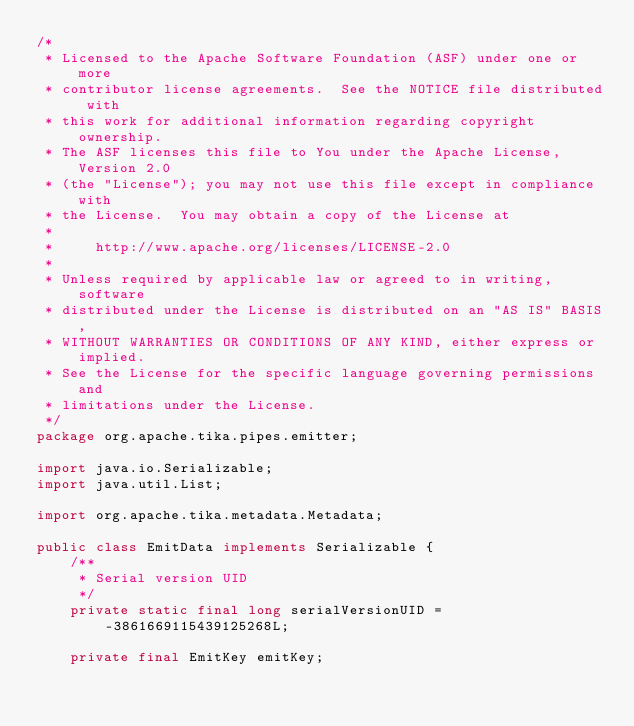<code> <loc_0><loc_0><loc_500><loc_500><_Java_>/*
 * Licensed to the Apache Software Foundation (ASF) under one or more
 * contributor license agreements.  See the NOTICE file distributed with
 * this work for additional information regarding copyright ownership.
 * The ASF licenses this file to You under the Apache License, Version 2.0
 * (the "License"); you may not use this file except in compliance with
 * the License.  You may obtain a copy of the License at
 *
 *     http://www.apache.org/licenses/LICENSE-2.0
 *
 * Unless required by applicable law or agreed to in writing, software
 * distributed under the License is distributed on an "AS IS" BASIS,
 * WITHOUT WARRANTIES OR CONDITIONS OF ANY KIND, either express or implied.
 * See the License for the specific language governing permissions and
 * limitations under the License.
 */
package org.apache.tika.pipes.emitter;

import java.io.Serializable;
import java.util.List;

import org.apache.tika.metadata.Metadata;

public class EmitData implements Serializable {
    /**
     * Serial version UID
     */
    private static final long serialVersionUID = -3861669115439125268L;

    private final EmitKey emitKey;</code> 